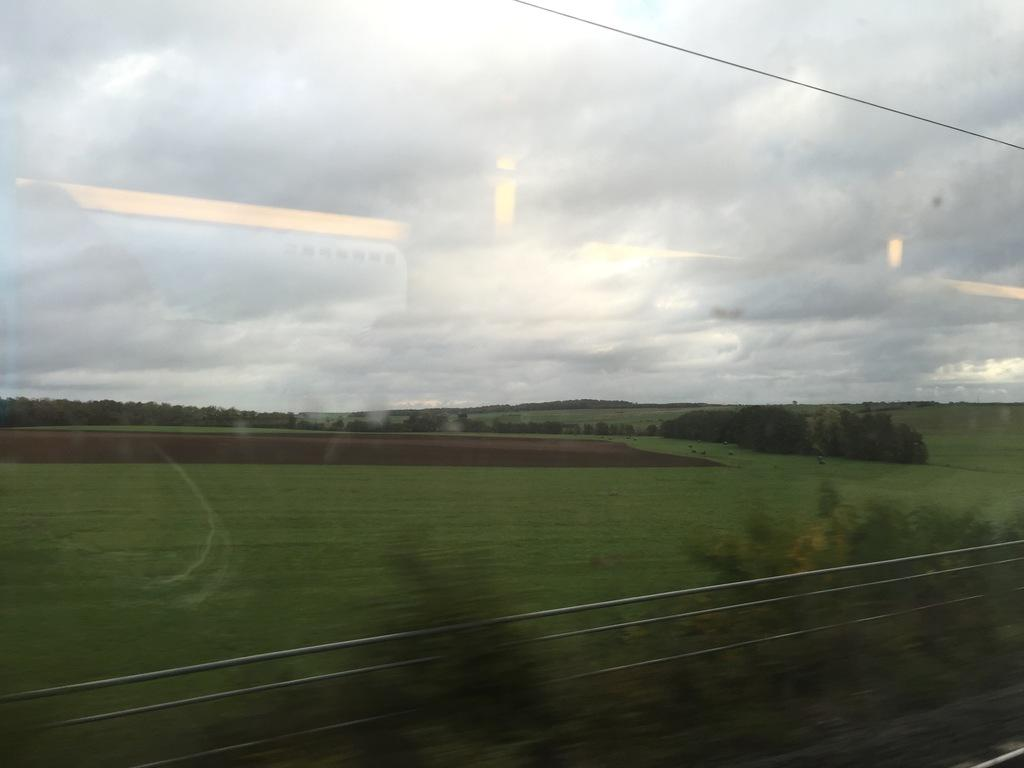What is the main subject of the image? There is a photo in the image. From where was the photo taken? The photo appears to be taken from a vehicle. What type of vegetation can be seen in the image? There are trees visible in the image. What is the ground covered with in the image? There is grass on the ground in the image. What is visible at the top of the image? The sky is visible at the top of the image. What can be seen in the sky? Clouds are present in the sky. Can you hear any songs being played in the image? There is no indication of any songs being played in the image. 